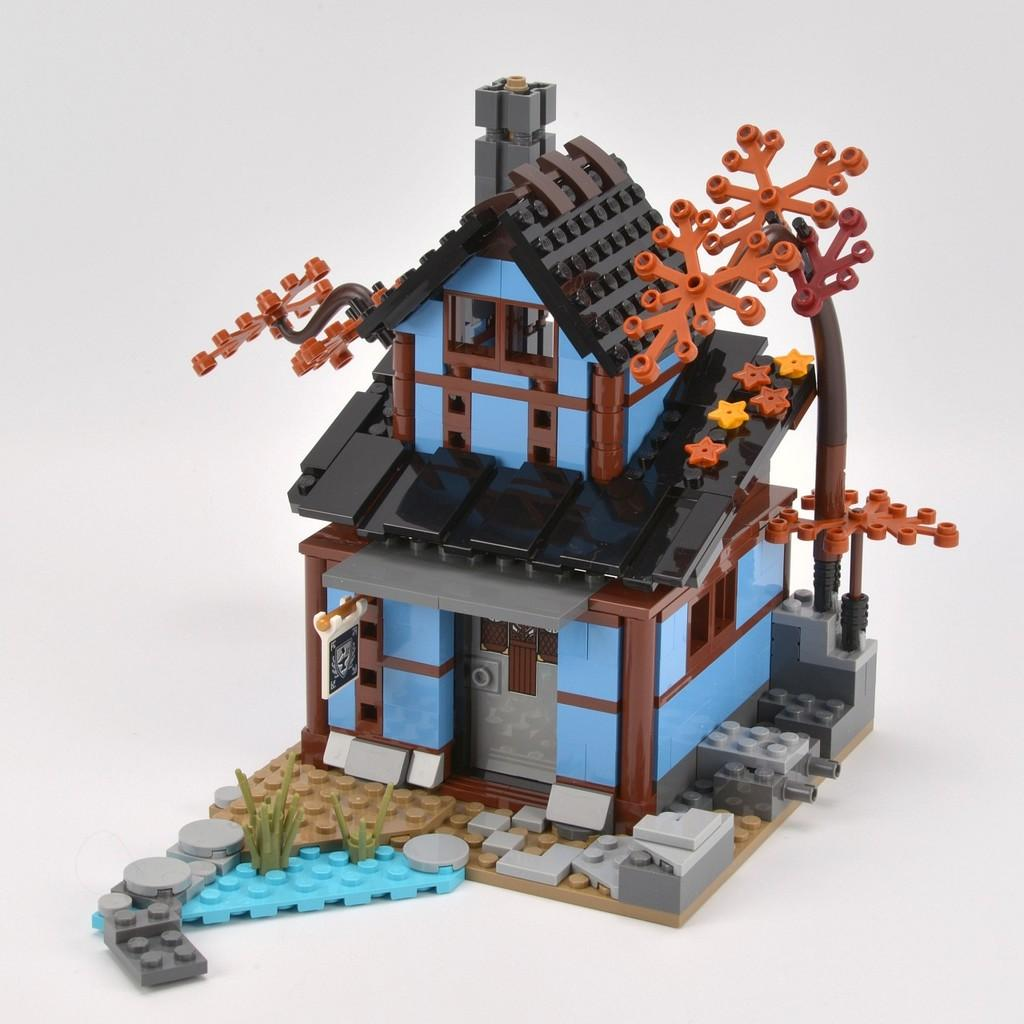What is the main subject of the image? The main subject of the image is a miniature house. What colors can be seen on the miniature house? The miniature house has black, blue, brown, and ash colors. What is the color of the surface on which the miniature house is placed? The miniature house is on a white surface. Can you tell me how many cushions are placed on the miniature house in the image? There are no cushions present in the image; it features a miniature house with specific colors and is placed on a white surface. 